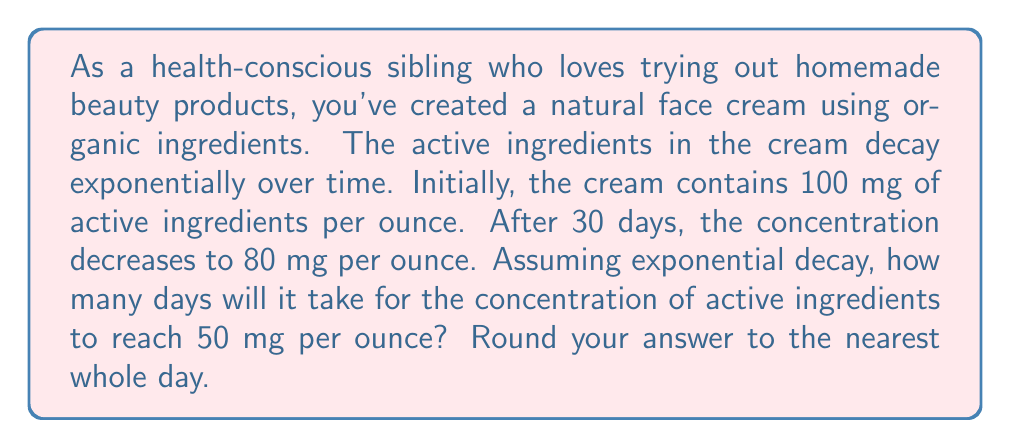Help me with this question. Let's approach this problem step-by-step using the exponential decay formula and logarithms:

1) The exponential decay formula is:
   $A(t) = A_0 e^{-kt}$
   Where:
   $A(t)$ is the amount at time $t$
   $A_0$ is the initial amount
   $k$ is the decay constant
   $t$ is time

2) We know:
   $A_0 = 100$ mg/oz (initial concentration)
   $A(30) = 80$ mg/oz (concentration after 30 days)
   We need to find $t$ when $A(t) = 50$ mg/oz

3) First, let's find the decay constant $k$ using the given information:
   $80 = 100 e^{-30k}$
   $\frac{80}{100} = e^{-30k}$
   $0.8 = e^{-30k}$

4) Taking the natural log of both sides:
   $\ln(0.8) = -30k$
   $k = -\frac{\ln(0.8)}{30} \approx 0.00743$

5) Now, let's use this $k$ value in our original equation to find $t$ when $A(t) = 50$:
   $50 = 100 e^{-0.00743t}$
   $0.5 = e^{-0.00743t}$

6) Taking the natural log of both sides:
   $\ln(0.5) = -0.00743t$

7) Solving for $t$:
   $t = -\frac{\ln(0.5)}{0.00743} \approx 93.24$ days

8) Rounding to the nearest whole day:
   $t \approx 93$ days
Answer: 93 days 